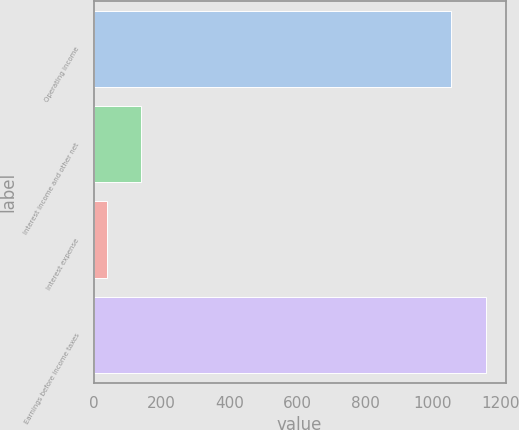<chart> <loc_0><loc_0><loc_500><loc_500><bar_chart><fcel>Operating income<fcel>Interest income and other net<fcel>Interest expense<fcel>Earnings before income taxes<nl><fcel>1053.9<fcel>139.83<fcel>38<fcel>1155.73<nl></chart> 